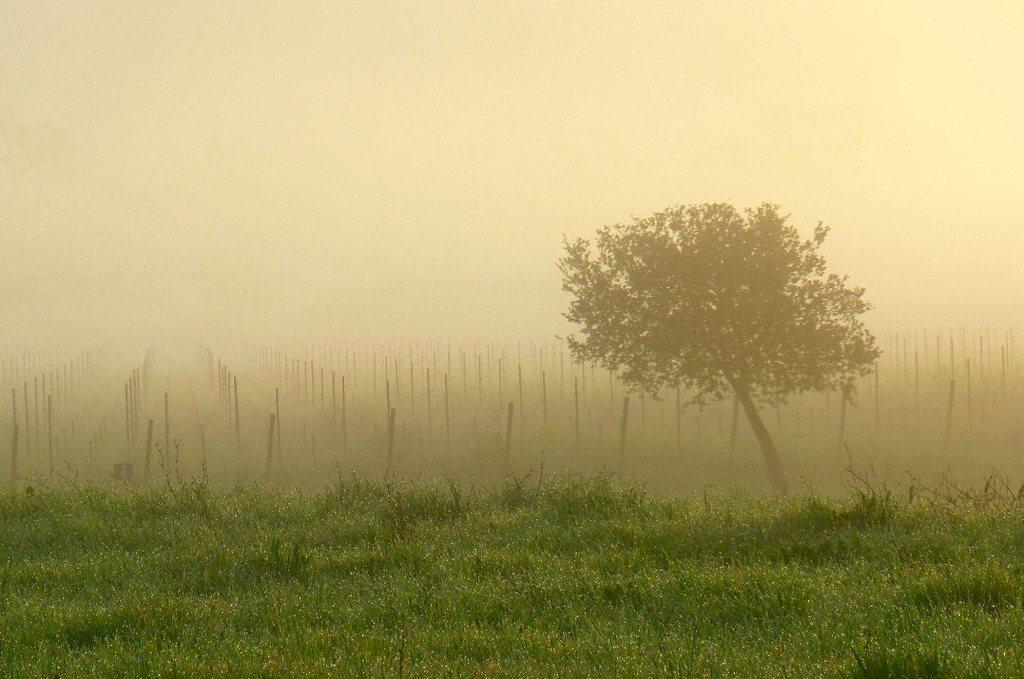What type of vegetation is present in the image? There is a tree and plants in the image. What else can be seen in the image besides vegetation? There are sticks visible in the image. What atmospheric condition is present in the image? There is fog visible in the image. How many pencils can be seen in the image? There are no pencils present in the image. What type of scale is used to measure the size of the tree in the image? There is no scale present in the image, and the size of the tree is not being measured. 